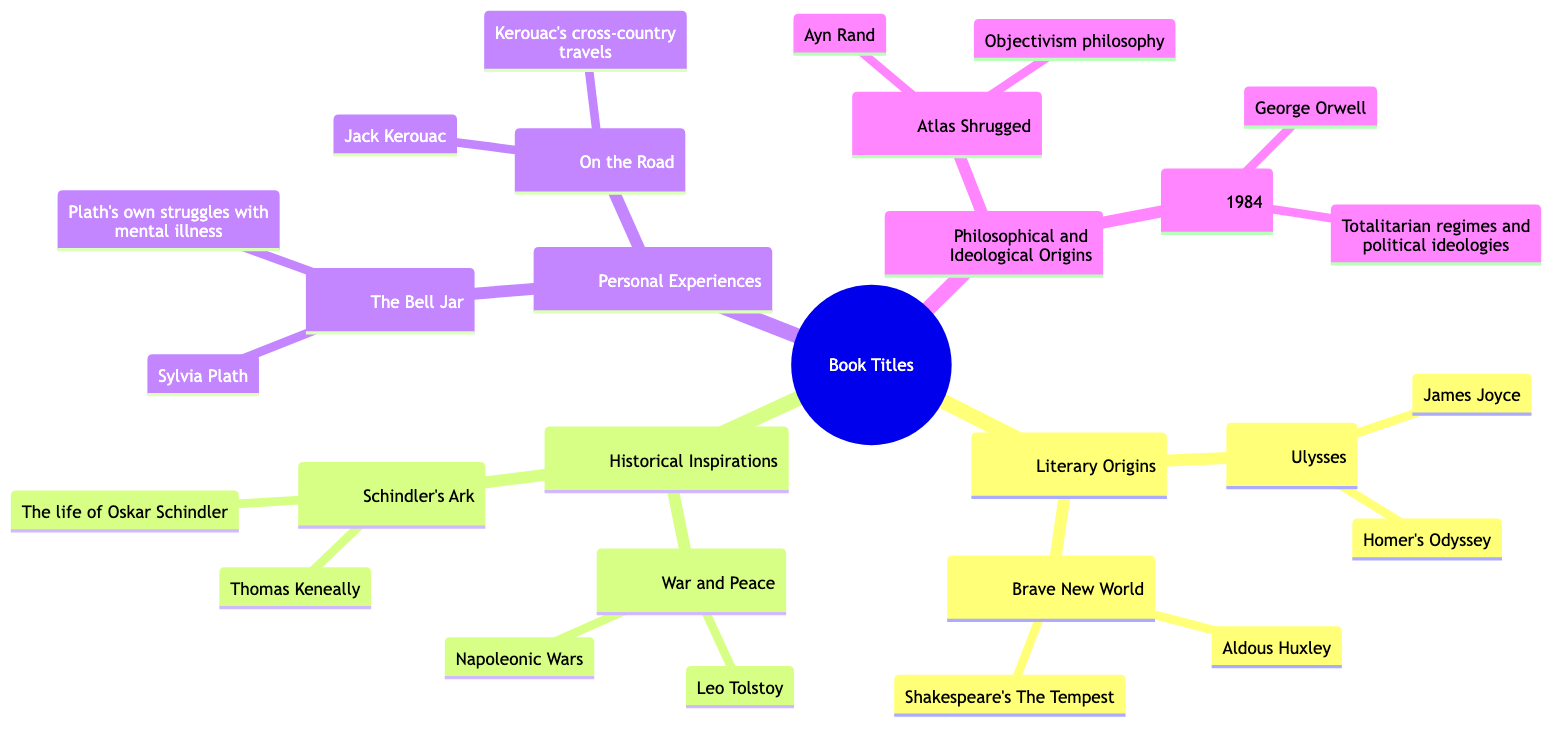What is the central node in the diagram? The central node is labeled “Book Titles,” which indicates the main theme of the family tree. The diagram focuses on exploring the sources and inspirations behind iconic book titles.
Answer: Book Titles How many children does “Literary Origins” have? The “Literary Origins” node has two child nodes: “Ulysses” and “Brave New World.” This can be counted directly from the diagram under the “Literary Origins” section.
Answer: 2 Who is the author of “1984”? The author of “1984” is listed as George Orwell in the diagram. This information can be found directly under the node for “1984.”
Answer: George Orwell What is the inspiration behind “The Bell Jar”? The inspiration behind “The Bell Jar” is Sylvia Plath's own struggles with mental illness. This information is provided under the “The Bell Jar” node.
Answer: Plath’s own struggles with mental illness Which category includes the book “Schindler’s Ark”? “Schindler’s Ark” falls under the category of “Historical Inspirations” within the diagram. This can be identified by locating the node associated with “Schindler’s Ark.”
Answer: Historical Inspirations Which book title is inspired by the philosophy of Objectivism? The book inspired by the philosophy of Objectivism is “Atlas Shrugged.” This can be confirmed within the “Philosophical and Ideological Origins” section of the diagram.
Answer: Atlas Shrugged How many nodes are there under the “Personal Experiences” category? Under the “Personal Experiences” category, there are two nodes: “The Bell Jar” and “On the Road.” This can be counted directly from that section of the family tree.
Answer: 2 What is the connection between “War and Peace” and its title inspiration? “War and Peace” is inspired by the Napoleonic Wars, as indicated in the diagram. This relationship is found directly under the “War and Peace” title node.
Answer: Napoleonic Wars Which author is associated with “Ulysses”? The author of “Ulysses” is James Joyce, as stated in the diagram beneath the corresponding book title node.
Answer: James Joyce 